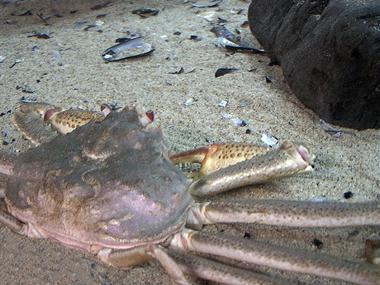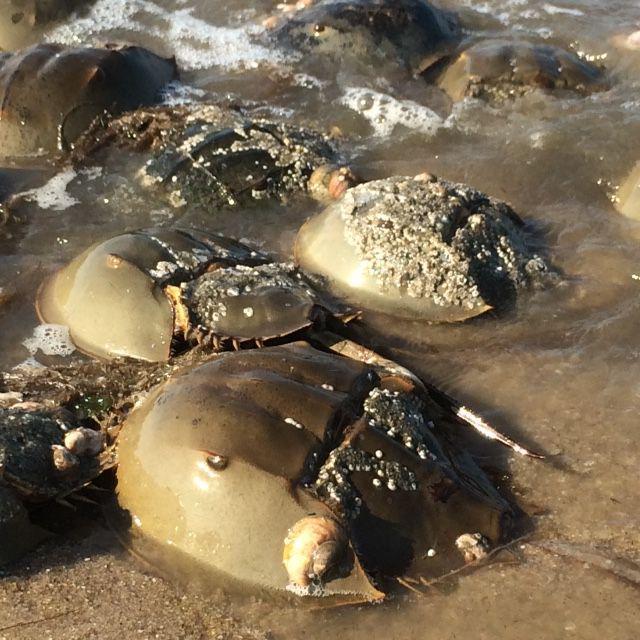The first image is the image on the left, the second image is the image on the right. Evaluate the accuracy of this statement regarding the images: "The right image is a top-view of a crab on dry sand, with its shell face-up and dotted with barnacles.". Is it true? Answer yes or no. No. 